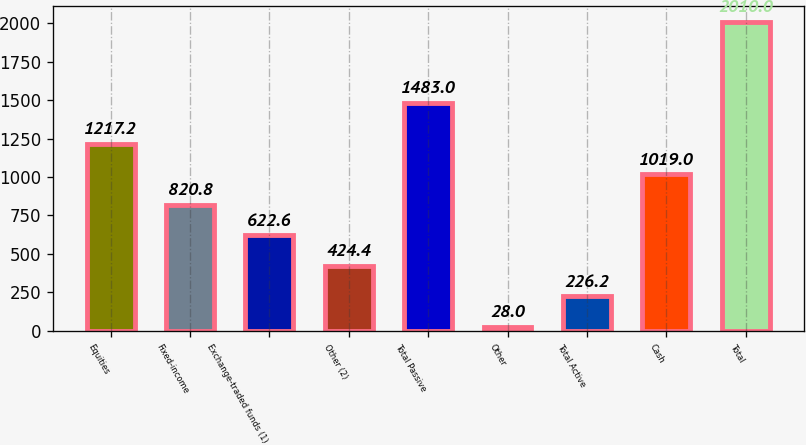Convert chart. <chart><loc_0><loc_0><loc_500><loc_500><bar_chart><fcel>Equities<fcel>Fixed-income<fcel>Exchange-traded funds (1)<fcel>Other (2)<fcel>Total Passive<fcel>Other<fcel>Total Active<fcel>Cash<fcel>Total<nl><fcel>1217.2<fcel>820.8<fcel>622.6<fcel>424.4<fcel>1483<fcel>28<fcel>226.2<fcel>1019<fcel>2010<nl></chart> 